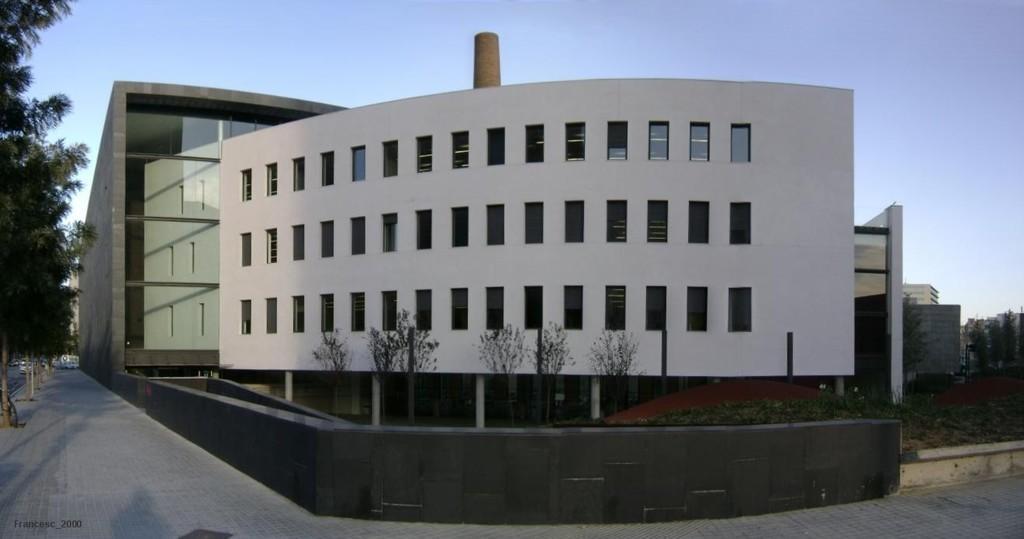How would you summarize this image in a sentence or two? In this image we can see a few buildings, plants, trees, grass, there is a vehicle, a bicycle, also we can see the sky. 